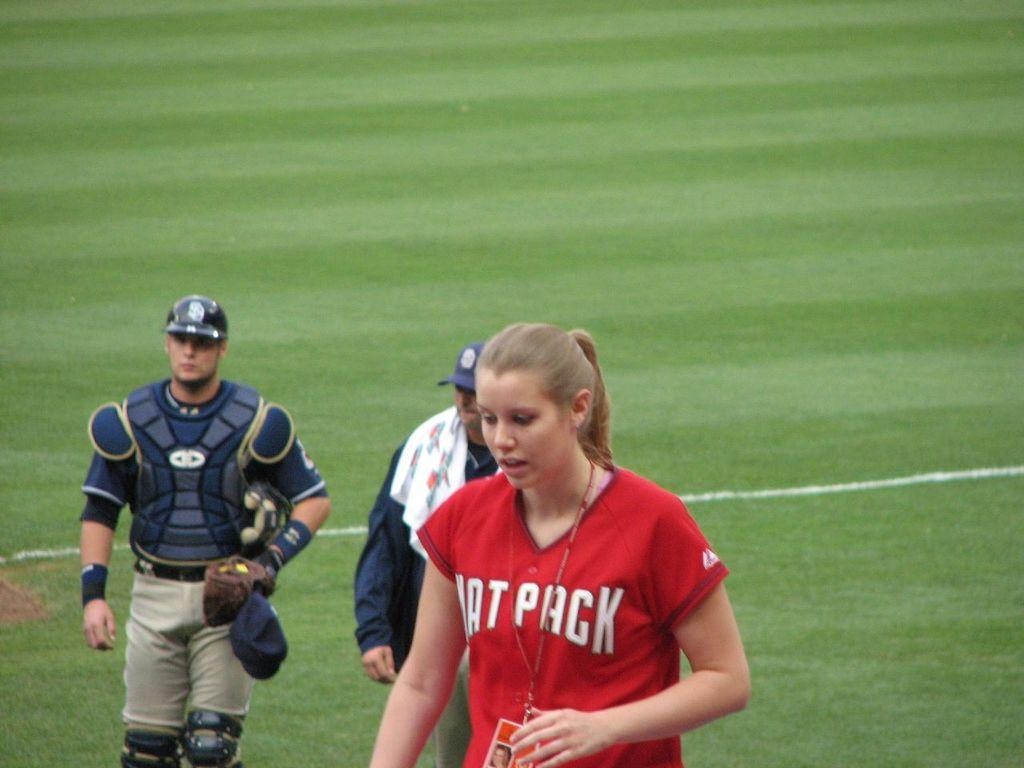<image>
Relay a brief, clear account of the picture shown. A woman with the word "pack" on her shirt is wearing an identification lanyard around her neck. 